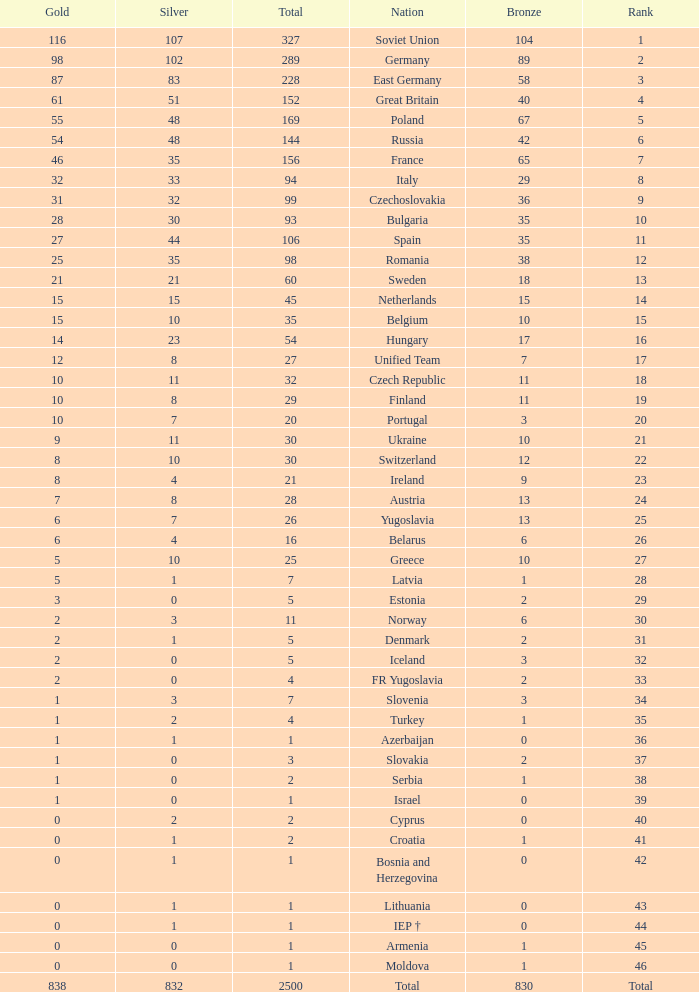Could you help me parse every detail presented in this table? {'header': ['Gold', 'Silver', 'Total', 'Nation', 'Bronze', 'Rank'], 'rows': [['116', '107', '327', 'Soviet Union', '104', '1'], ['98', '102', '289', 'Germany', '89', '2'], ['87', '83', '228', 'East Germany', '58', '3'], ['61', '51', '152', 'Great Britain', '40', '4'], ['55', '48', '169', 'Poland', '67', '5'], ['54', '48', '144', 'Russia', '42', '6'], ['46', '35', '156', 'France', '65', '7'], ['32', '33', '94', 'Italy', '29', '8'], ['31', '32', '99', 'Czechoslovakia', '36', '9'], ['28', '30', '93', 'Bulgaria', '35', '10'], ['27', '44', '106', 'Spain', '35', '11'], ['25', '35', '98', 'Romania', '38', '12'], ['21', '21', '60', 'Sweden', '18', '13'], ['15', '15', '45', 'Netherlands', '15', '14'], ['15', '10', '35', 'Belgium', '10', '15'], ['14', '23', '54', 'Hungary', '17', '16'], ['12', '8', '27', 'Unified Team', '7', '17'], ['10', '11', '32', 'Czech Republic', '11', '18'], ['10', '8', '29', 'Finland', '11', '19'], ['10', '7', '20', 'Portugal', '3', '20'], ['9', '11', '30', 'Ukraine', '10', '21'], ['8', '10', '30', 'Switzerland', '12', '22'], ['8', '4', '21', 'Ireland', '9', '23'], ['7', '8', '28', 'Austria', '13', '24'], ['6', '7', '26', 'Yugoslavia', '13', '25'], ['6', '4', '16', 'Belarus', '6', '26'], ['5', '10', '25', 'Greece', '10', '27'], ['5', '1', '7', 'Latvia', '1', '28'], ['3', '0', '5', 'Estonia', '2', '29'], ['2', '3', '11', 'Norway', '6', '30'], ['2', '1', '5', 'Denmark', '2', '31'], ['2', '0', '5', 'Iceland', '3', '32'], ['2', '0', '4', 'FR Yugoslavia', '2', '33'], ['1', '3', '7', 'Slovenia', '3', '34'], ['1', '2', '4', 'Turkey', '1', '35'], ['1', '1', '1', 'Azerbaijan', '0', '36'], ['1', '0', '3', 'Slovakia', '2', '37'], ['1', '0', '2', 'Serbia', '1', '38'], ['1', '0', '1', 'Israel', '0', '39'], ['0', '2', '2', 'Cyprus', '0', '40'], ['0', '1', '2', 'Croatia', '1', '41'], ['0', '1', '1', 'Bosnia and Herzegovina', '0', '42'], ['0', '1', '1', 'Lithuania', '0', '43'], ['0', '1', '1', 'IEP †', '0', '44'], ['0', '0', '1', 'Armenia', '1', '45'], ['0', '0', '1', 'Moldova', '1', '46'], ['838', '832', '2500', 'Total', '830', 'Total']]} What is the rank of the nation with more than 0 silver medals and 38 bronze medals? 12.0. 